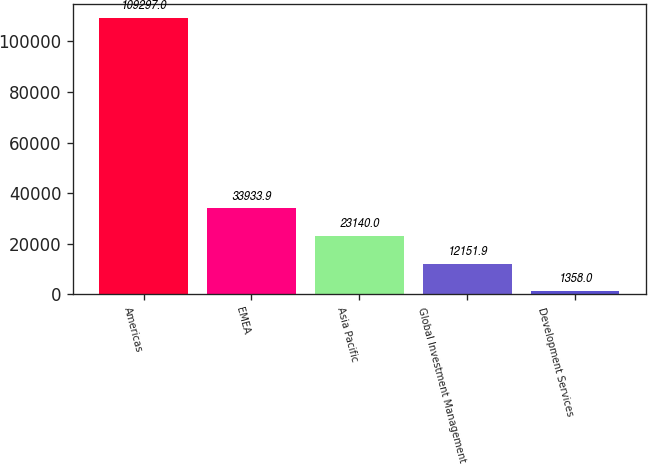Convert chart. <chart><loc_0><loc_0><loc_500><loc_500><bar_chart><fcel>Americas<fcel>EMEA<fcel>Asia Pacific<fcel>Global Investment Management<fcel>Development Services<nl><fcel>109297<fcel>33933.9<fcel>23140<fcel>12151.9<fcel>1358<nl></chart> 